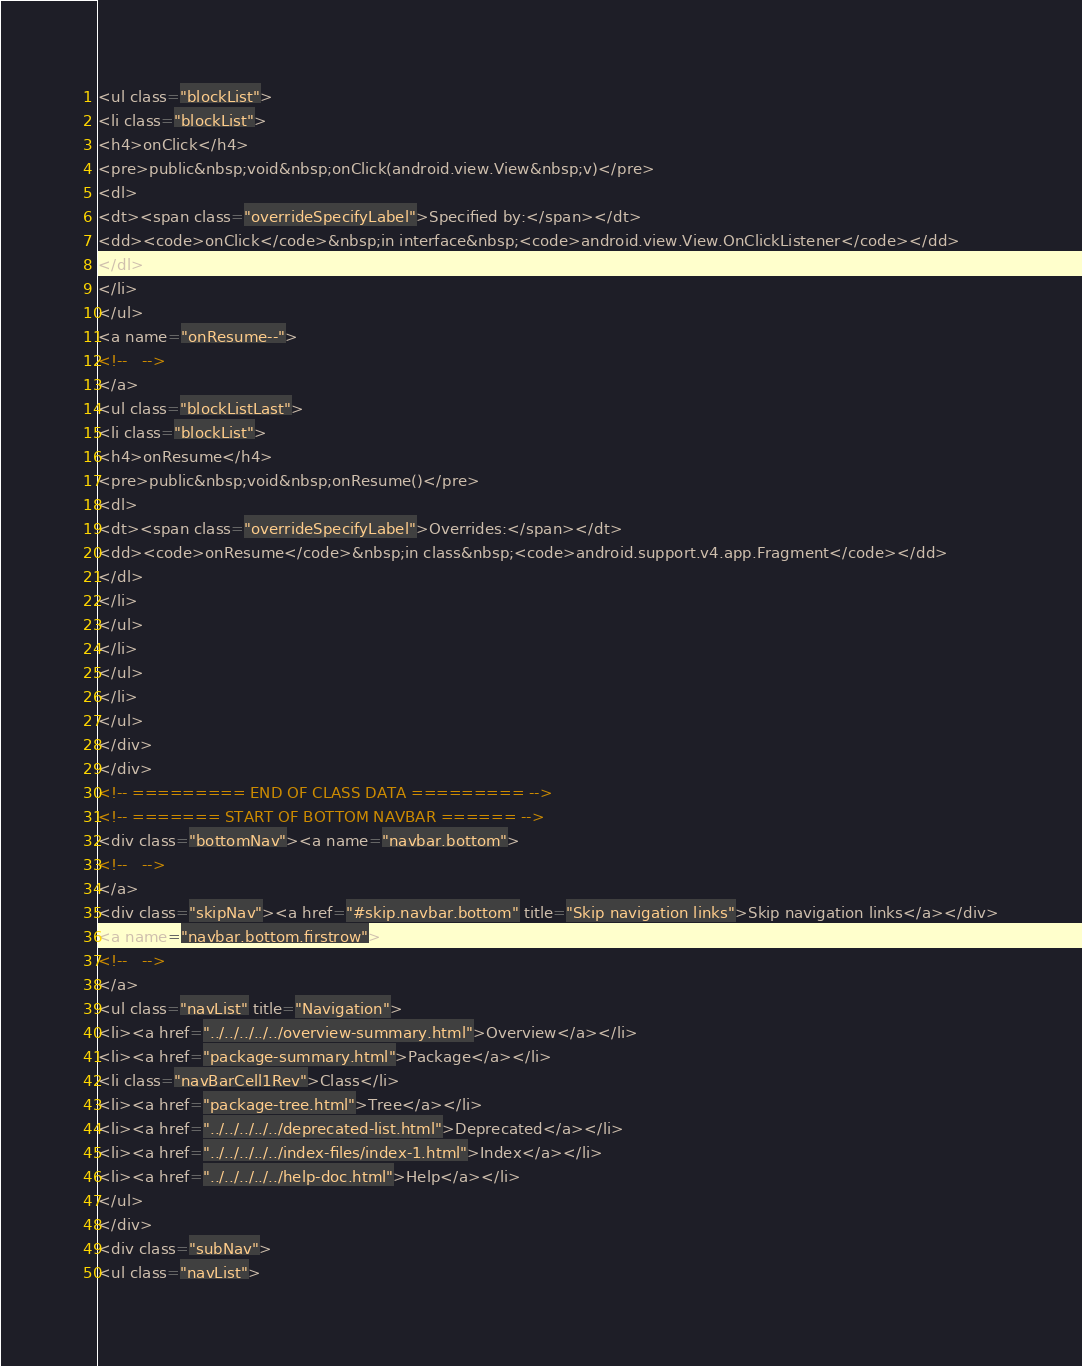<code> <loc_0><loc_0><loc_500><loc_500><_HTML_><ul class="blockList">
<li class="blockList">
<h4>onClick</h4>
<pre>public&nbsp;void&nbsp;onClick(android.view.View&nbsp;v)</pre>
<dl>
<dt><span class="overrideSpecifyLabel">Specified by:</span></dt>
<dd><code>onClick</code>&nbsp;in interface&nbsp;<code>android.view.View.OnClickListener</code></dd>
</dl>
</li>
</ul>
<a name="onResume--">
<!--   -->
</a>
<ul class="blockListLast">
<li class="blockList">
<h4>onResume</h4>
<pre>public&nbsp;void&nbsp;onResume()</pre>
<dl>
<dt><span class="overrideSpecifyLabel">Overrides:</span></dt>
<dd><code>onResume</code>&nbsp;in class&nbsp;<code>android.support.v4.app.Fragment</code></dd>
</dl>
</li>
</ul>
</li>
</ul>
</li>
</ul>
</div>
</div>
<!-- ========= END OF CLASS DATA ========= -->
<!-- ======= START OF BOTTOM NAVBAR ====== -->
<div class="bottomNav"><a name="navbar.bottom">
<!--   -->
</a>
<div class="skipNav"><a href="#skip.navbar.bottom" title="Skip navigation links">Skip navigation links</a></div>
<a name="navbar.bottom.firstrow">
<!--   -->
</a>
<ul class="navList" title="Navigation">
<li><a href="../../../../../overview-summary.html">Overview</a></li>
<li><a href="package-summary.html">Package</a></li>
<li class="navBarCell1Rev">Class</li>
<li><a href="package-tree.html">Tree</a></li>
<li><a href="../../../../../deprecated-list.html">Deprecated</a></li>
<li><a href="../../../../../index-files/index-1.html">Index</a></li>
<li><a href="../../../../../help-doc.html">Help</a></li>
</ul>
</div>
<div class="subNav">
<ul class="navList"></code> 